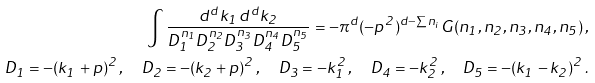Convert formula to latex. <formula><loc_0><loc_0><loc_500><loc_500>\int \frac { d ^ { d } k _ { 1 } \, d ^ { d } k _ { 2 } } { D _ { 1 } ^ { n _ { 1 } } D _ { 2 } ^ { n _ { 2 } } D _ { 3 } ^ { n _ { 3 } } D _ { 4 } ^ { n _ { 4 } } D _ { 5 } ^ { n _ { 5 } } } = - \pi ^ { d } ( - p ^ { 2 } ) ^ { d - \sum n _ { i } } G ( n _ { 1 } , n _ { 2 } , n _ { 3 } , n _ { 4 } , n _ { 5 } ) \, , \\ D _ { 1 } = - ( k _ { 1 } + p ) ^ { 2 } \, , \quad D _ { 2 } = - ( k _ { 2 } + p ) ^ { 2 } \, , \quad D _ { 3 } = - k _ { 1 } ^ { 2 } \, , \quad D _ { 4 } = - k _ { 2 } ^ { 2 } \, , \quad D _ { 5 } = - ( k _ { 1 } - k _ { 2 } ) ^ { 2 } \, .</formula> 